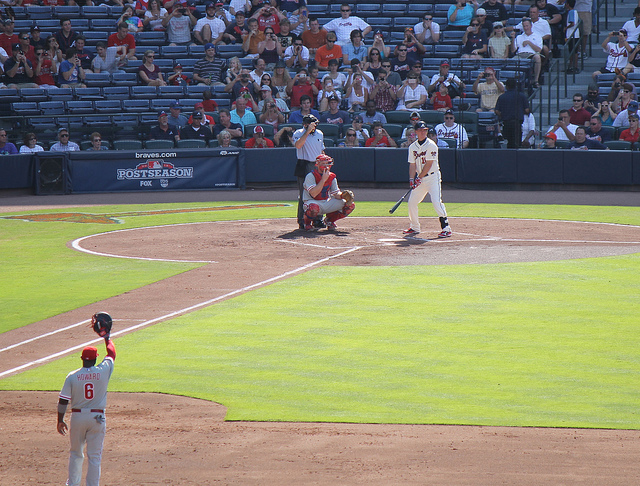<image>What number is the pitcher wearing? It is unknown what number the pitcher is wearing. It can be '6' or '1'. What number is the pitcher wearing? There is no pitcher shown in the image. 